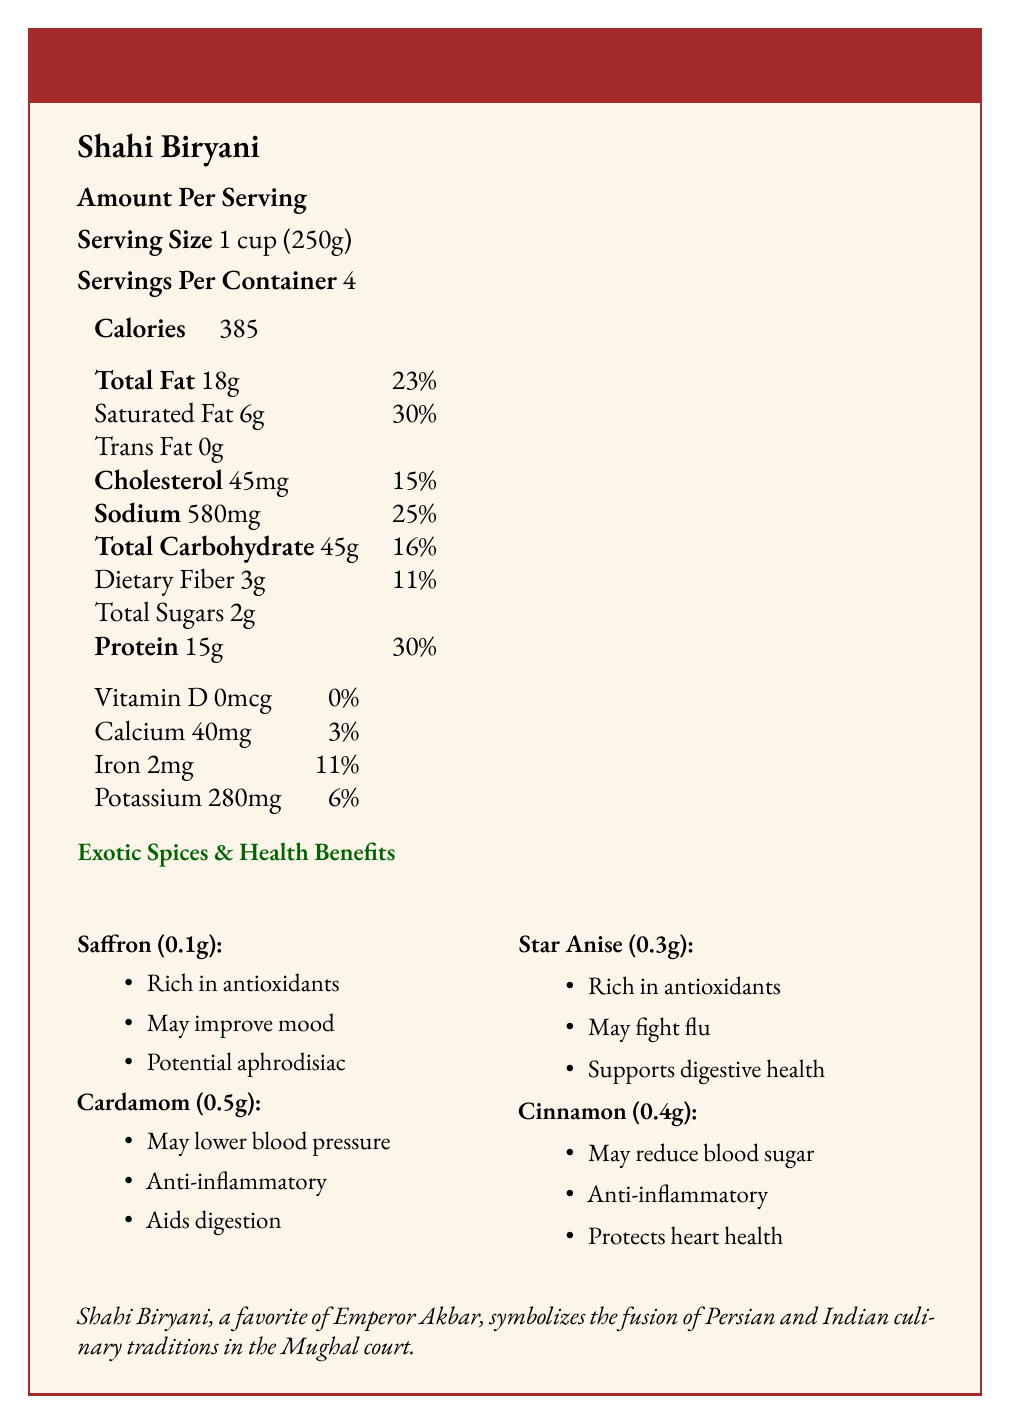what is the serving size? The document states the serving size is 1 cup (250g).
Answer: 1 cup (250g) how many servings are there per container? The document lists servings per container as 4.
Answer: 4 how many calories are in one serving of Shahi Biryani? The document specifies that one serving contains 385 calories.
Answer: 385 which vitamin is completely absent in Shahi Biryani? The document indicates that the amount of Vitamin D is 0mcg, meaning it is absent.
Answer: Vitamin D how much sodium is in one serving? The document lists 580mg of sodium per serving.
Answer: 580mg which spice is used in the highest quantity in the Shahi Biryani according to the document? A. Saffron B. Cardamom C. Star Anise D. Cinnamon The document notes the amount of Cardamom is 0.5g, which is higher compared to Saffron (0.1g), Star Anise (0.3g), and Cinnamon (0.4g).
Answer: B. Cardamom which health benefit is NOT associated with saffron according to the document? A. Contains antioxidants B. Improves mood C. Reduces blood sugar D. Has aphrodisiac properties The document lists that Saffron is rich in antioxidants, may improve mood, and potential aphrodisiac properties, but does not mention reducing blood sugar levels.
Answer: C. Reduces blood sugar does Shahi Biryani contain any trans fat? According to the document, Shahi Biryani contains 0g of trans fat.
Answer: No summarize the nutritional and cultural significance of Shahi Biryani according to the document. The summary highlights the main points about the nutritional content, exotic spices with their health benefits, and the historical and cultural context of Shahi Biryani as described in the document.
Answer: Shahi Biryani is a traditional Mughal dish known for its rich flavors and aromatic spices. A serving size of 1 cup (250g) contains 385 calories, 18g of total fat, 15g of protein, and various vitamins and minerals. The dish uses several exotic spices including Saffron, Cardamom, Star Anise, and Cinnamon, each with its unique health benefits. Shahi Biryani symbolizes the fusion of Persian and Indian culinary traditions and was a favorite of Emperor Akbar. what is the historical context of Shahi Biryani? The document states that the dish was favored by Emperor Akbar and was a symbol of the fusion of Persian and Indian culinary traditions in the Mughal Empire.
Answer: Shahi Biryani was a favorite dish of Emperor Akbar, symbolizing the fusion of Persian and Indian culinary traditions in the Mughal court, reflecting the empire's cultural diversity. how much saturated fat is in one serving of Shahi Biryani? The document states that there are 6g of saturated fat per serving.
Answer: 6g what is one health benefit of star anise mentioned in the document? A. May reduce blood sugar B. Contains anti-inflammatory compounds C. Supports digestive health D. Potential aphrodisiac The document lists supports digestive health as one of the health benefits of Star Anise.
Answer: C. Supports digestive health is the preparation method of Shahi Biryani mentioned in the document? The document describes that Shahi Biryani is slow-cooked in layers to blend the flavors of meat, rice, and spices.
Answer: Yes what type of meat is used in Shahi Biryani according to the document? The document lists lamb as one of the ingredients in Shahi Biryani.
Answer: Lamb how much dietary fiber is in one serving? The document states there are 3g of dietary fiber per serving.
Answer: 3g what is the total carbohydrate content in one serving? The document indicates that one serving contains 45g of total carbohydrates.
Answer: 45g who favored Shahi Biryani according to the historical context? The document mentions that Shahi Biryani was a favorite dish of Emperor Akbar.
Answer: Emperor Akbar how many grams of protein are in one serving? The document states that there are 15g of protein per serving.
Answer: 15g what is the exotic spice with potential aphrodisiac properties? The document lists potential aphrodisiac properties as one of the health benefits of Saffron.
Answer: Saffron which health benefit is common to both saffron and star anise? A. Anti-inflammatory properties B. Rich in antioxidants C. Supports digestive health D. May improve mood The document mentions that both Saffron and Star Anise are rich in antioxidants.
Answer: B. Rich in antioxidants which exotic spice may help lower blood pressure? According to the document, one of the health benefits of Cardamom is that it may lower blood pressure.
Answer: Cardamom what is the total percentage of Vitamin D in one serving? The document specifies that the total Vitamin D content is 0mcg, which is 0% of the daily value.
Answer: 0% how many servings would yield 1160mg of sodium? The document states there are 580mg of sodium per serving, so 2 servings would yield 1160mg of sodium (580mg x 2).
Answer: 2 servings which spice in Shahi Biryani could be protective against heart disease? The document lists protecting heart health as one of the benefits of Cinnamon.
Answer: Cinnamon what can be said about the nutritional content of Vitamin D in the document? The document shows that the amount of Vitamin D is 0mcg, indicating it is absent.
Answer: It is non-existent. how much iron is in one serving? The document notes that one serving contains 2mg of iron.
Answer: 2mg what is the cultural significance of the exotic spices used in Shahi Biryani? The document specifies that the spices were valued not only for their taste but also for their health benefits, reflecting the Mughal's holistic view regarding cuisine.
Answer: The exotic spices used in Shahi Biryani were prized for their flavors and medicinal properties, showcasing the Mughal's holistic approach to food and health. describe the preparation method of Shahi Biryani mentioned in the document. The document explains that Shahi Biryani is slow-cooked in layers to integrate the flavors of meat, rice, and spices harmoniously.
Answer: The preparation method involves slow-cooking in layers, allowing the flavors of meat, rice, and spices to meld together, creating a harmonious blend of tastes and aromas. how many grams of calcium are present per serving? The document states that each serving contains 40mg of calcium.
Answer: 40mg what is the main ingredient of Shahi Biryani? The document lists basmati rice as the first ingredient, indicating it is the main ingredient.
Answer: Basmati rice does the document provide enough information about how to prepare Shahi Biryani? The document mentions that Shahi Biryani is slow-cooked in layers but does not provide complete step-by-step instructions for its preparation.
Answer: Not enough information 